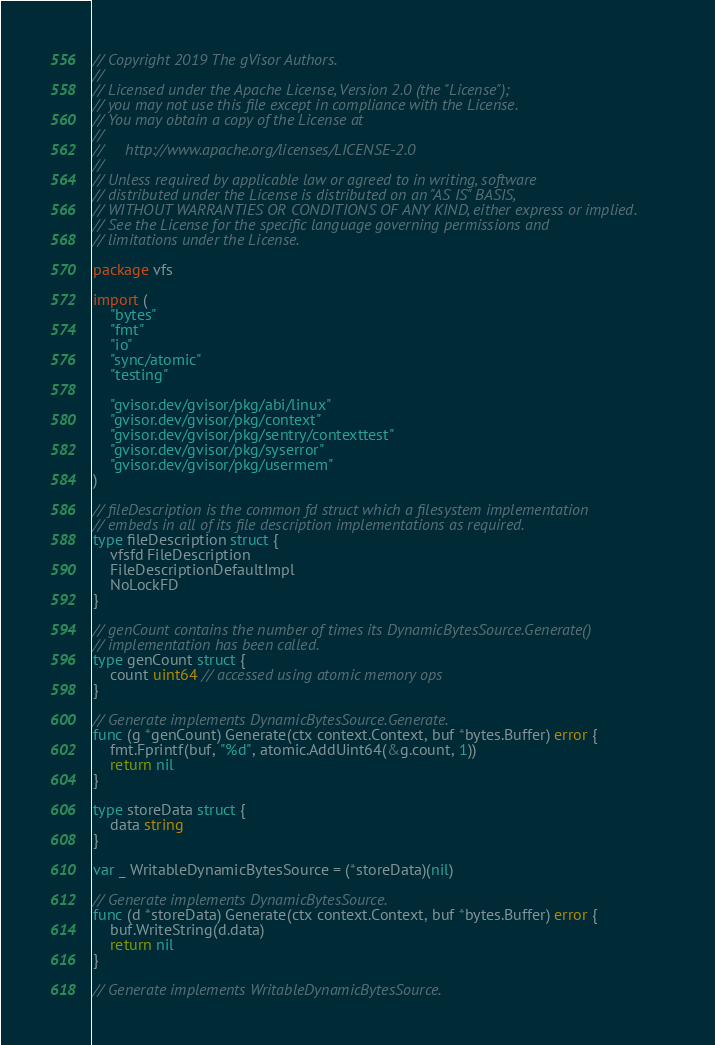<code> <loc_0><loc_0><loc_500><loc_500><_Go_>// Copyright 2019 The gVisor Authors.
//
// Licensed under the Apache License, Version 2.0 (the "License");
// you may not use this file except in compliance with the License.
// You may obtain a copy of the License at
//
//     http://www.apache.org/licenses/LICENSE-2.0
//
// Unless required by applicable law or agreed to in writing, software
// distributed under the License is distributed on an "AS IS" BASIS,
// WITHOUT WARRANTIES OR CONDITIONS OF ANY KIND, either express or implied.
// See the License for the specific language governing permissions and
// limitations under the License.

package vfs

import (
	"bytes"
	"fmt"
	"io"
	"sync/atomic"
	"testing"

	"gvisor.dev/gvisor/pkg/abi/linux"
	"gvisor.dev/gvisor/pkg/context"
	"gvisor.dev/gvisor/pkg/sentry/contexttest"
	"gvisor.dev/gvisor/pkg/syserror"
	"gvisor.dev/gvisor/pkg/usermem"
)

// fileDescription is the common fd struct which a filesystem implementation
// embeds in all of its file description implementations as required.
type fileDescription struct {
	vfsfd FileDescription
	FileDescriptionDefaultImpl
	NoLockFD
}

// genCount contains the number of times its DynamicBytesSource.Generate()
// implementation has been called.
type genCount struct {
	count uint64 // accessed using atomic memory ops
}

// Generate implements DynamicBytesSource.Generate.
func (g *genCount) Generate(ctx context.Context, buf *bytes.Buffer) error {
	fmt.Fprintf(buf, "%d", atomic.AddUint64(&g.count, 1))
	return nil
}

type storeData struct {
	data string
}

var _ WritableDynamicBytesSource = (*storeData)(nil)

// Generate implements DynamicBytesSource.
func (d *storeData) Generate(ctx context.Context, buf *bytes.Buffer) error {
	buf.WriteString(d.data)
	return nil
}

// Generate implements WritableDynamicBytesSource.</code> 